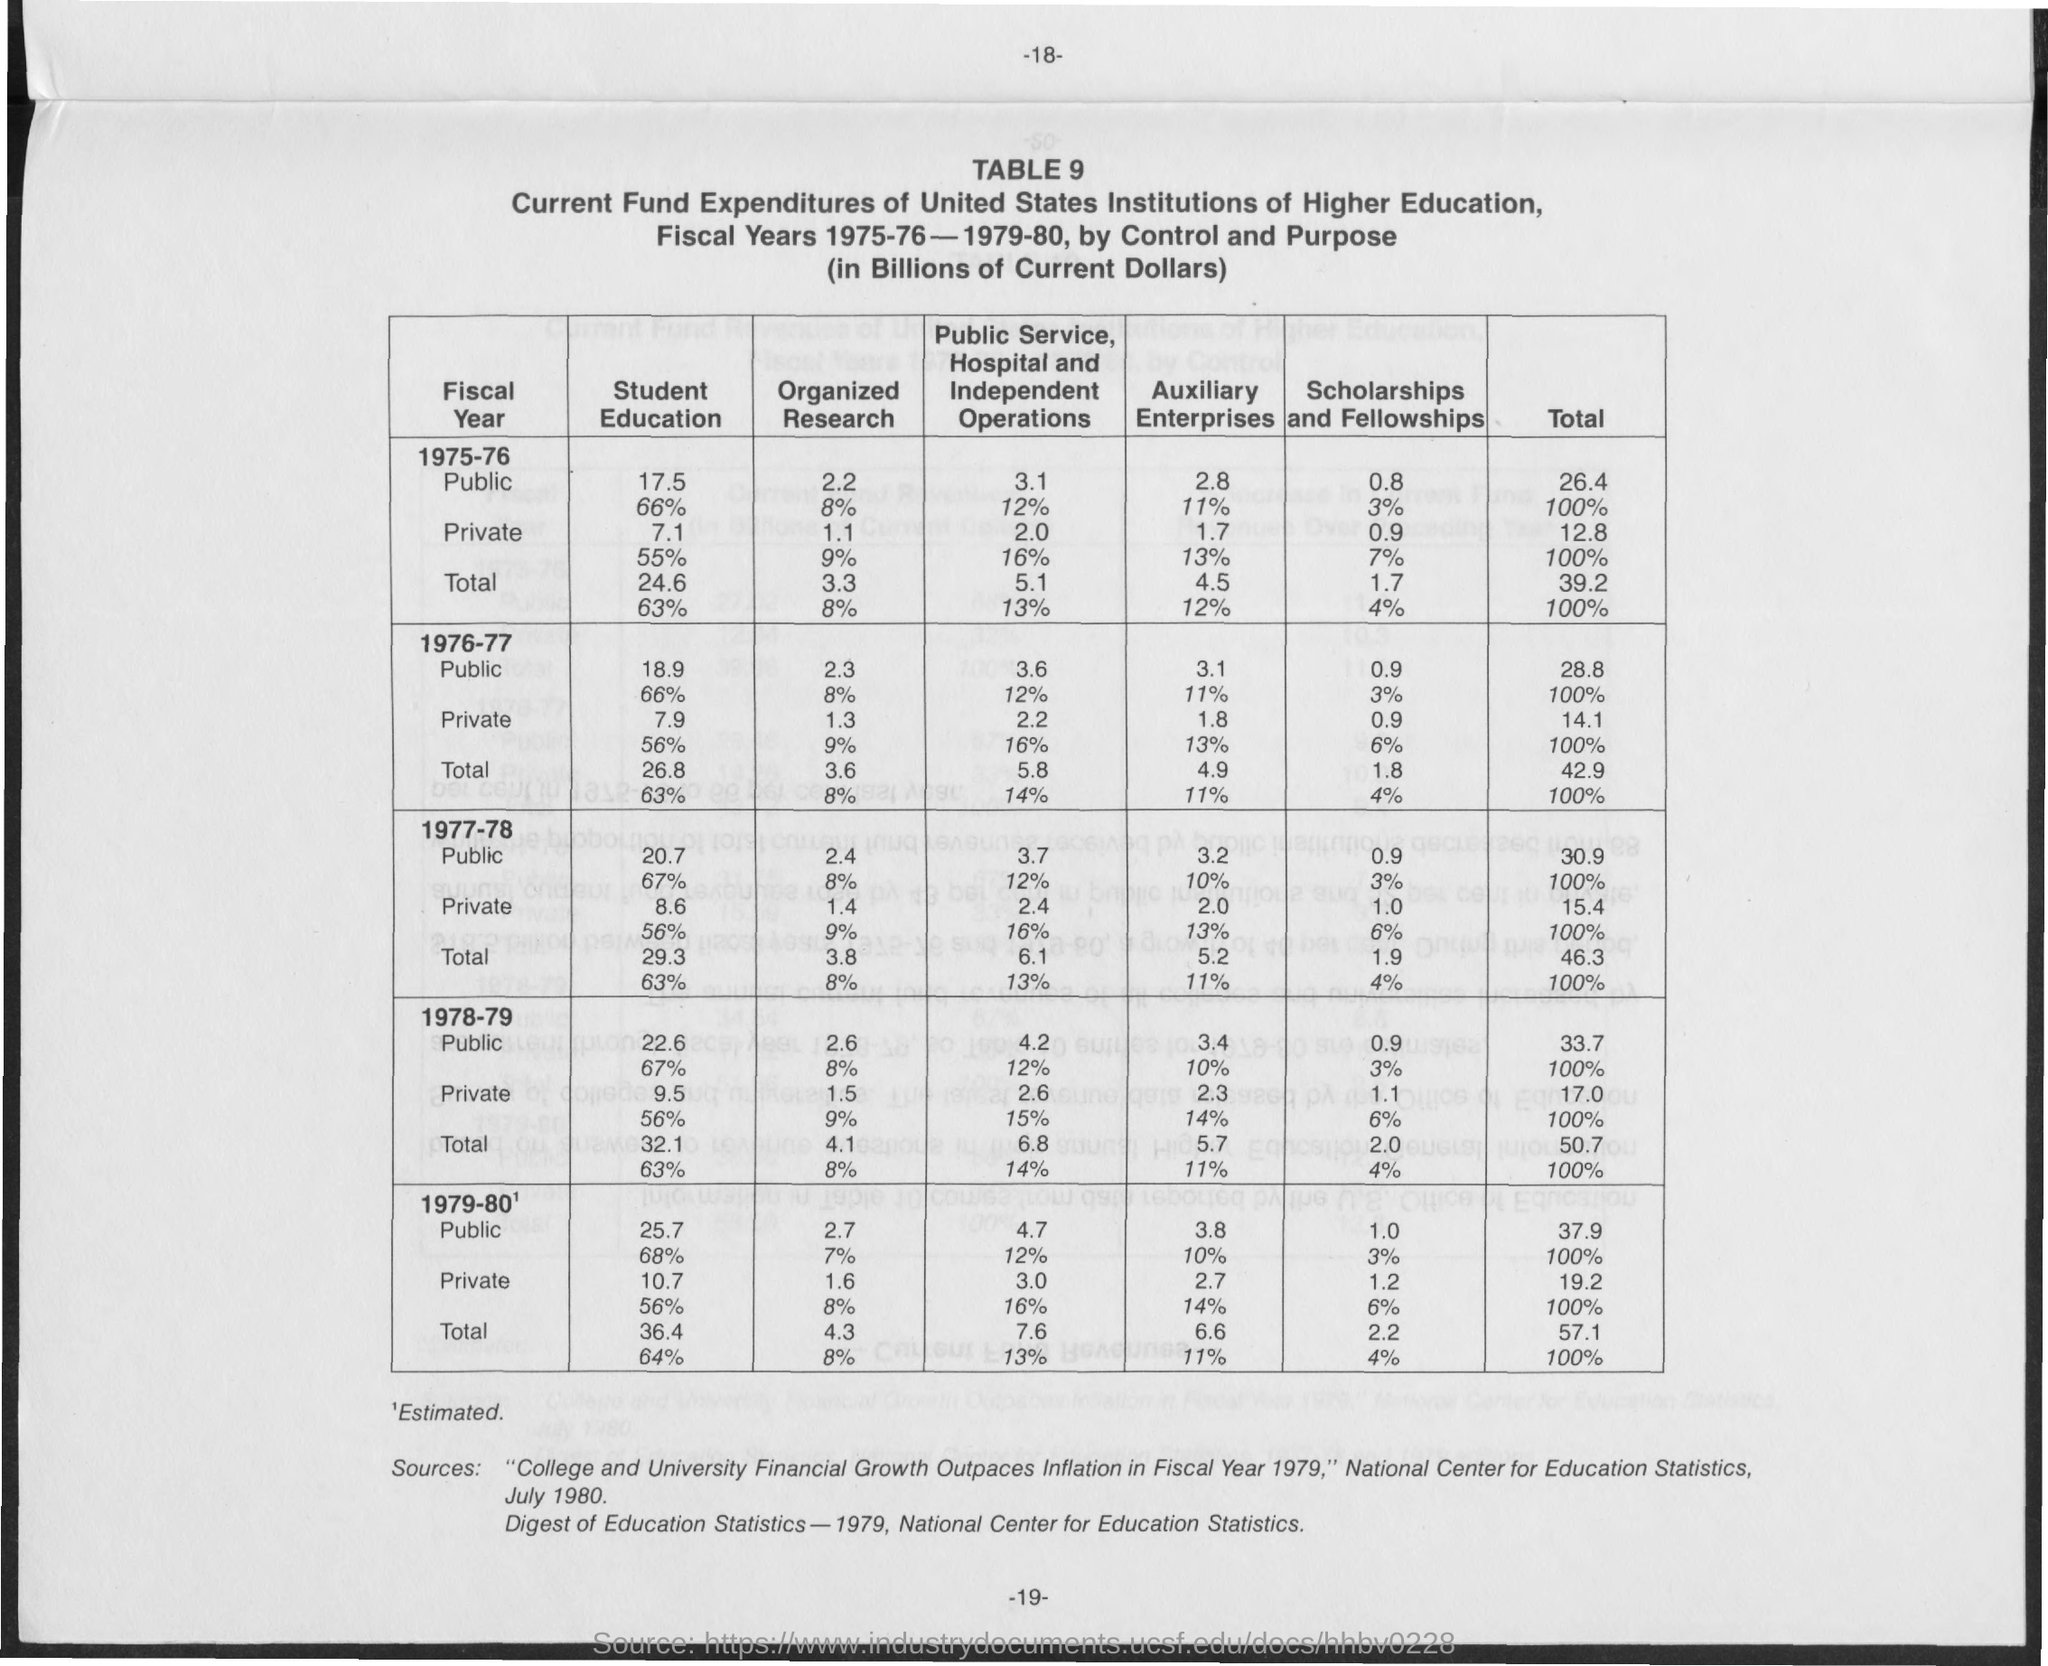What is the Page Number?
Make the answer very short. 18. 